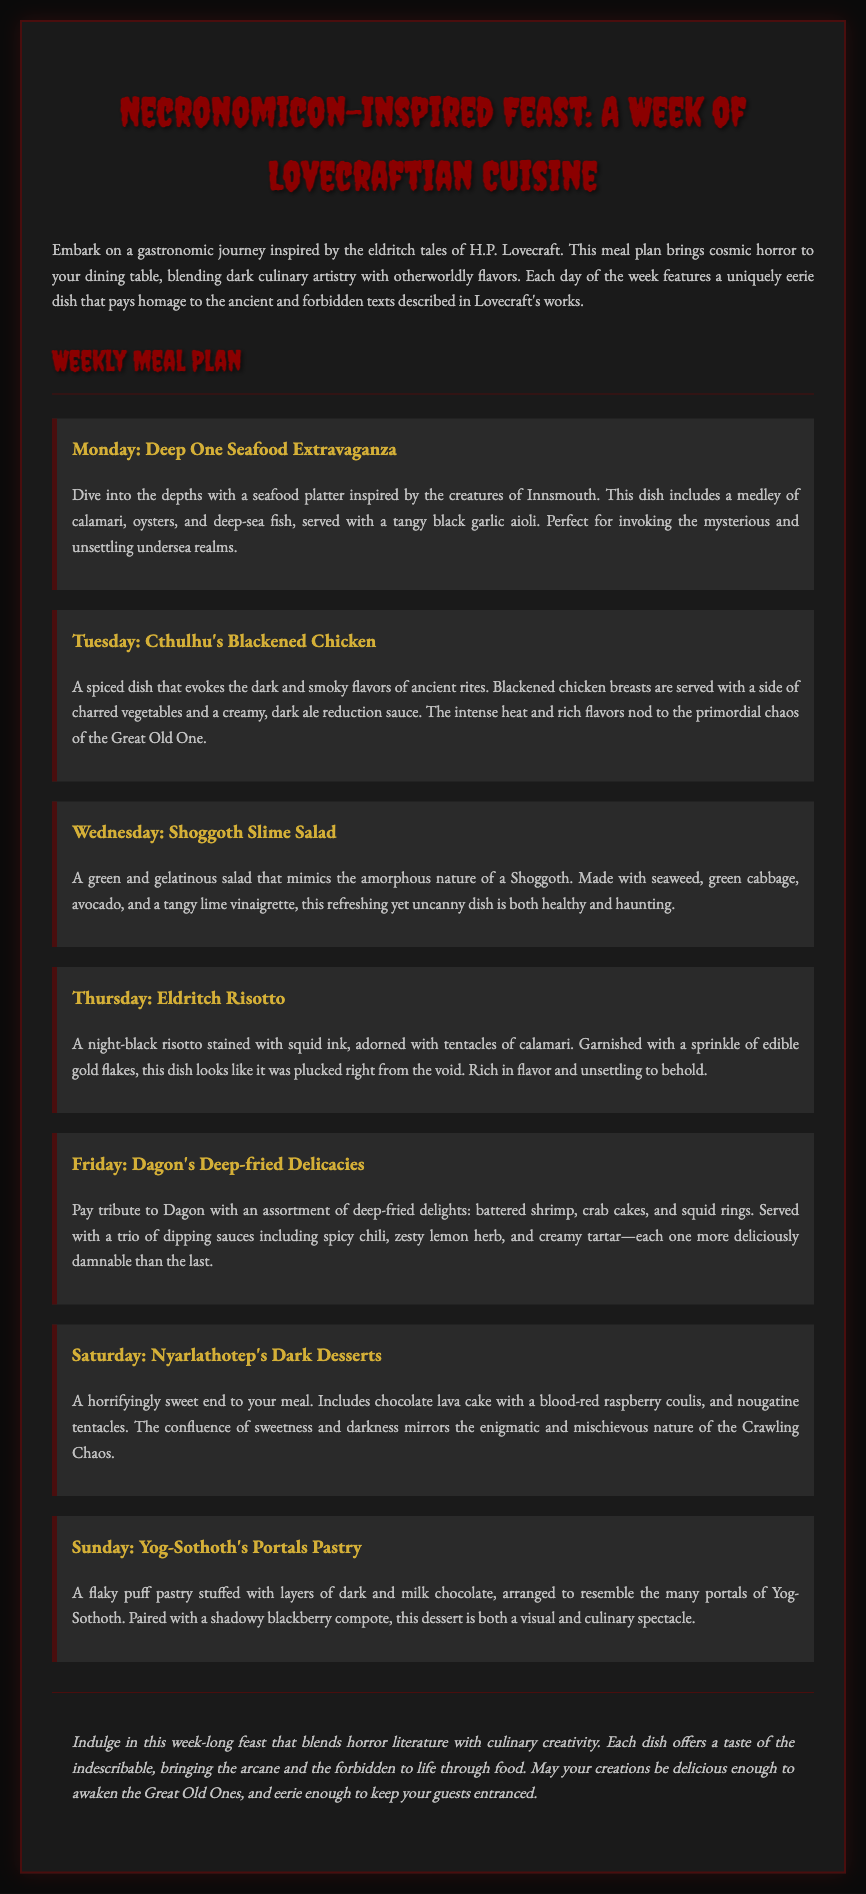What is the title of the meal plan? The title of the meal plan is prominently displayed at the top of the document.
Answer: Necronomicon-Inspired Feast: A Week of Lovecraftian Cuisine What type of cuisine is featured? The cuisine is described as being inspired by the works of H.P. Lovecraft, invoking a specific theme.
Answer: Lovecraftian Cuisine What dish is served on Monday? The dish for Monday is mentioned in the meal section of the document.
Answer: Deep One Seafood Extravaganza What is the main ingredient in the Eldritch Risotto? This dish is described with a specific ingredient that gives it its unique characteristic.
Answer: Squid ink How many different dipping sauces are served with Dagon's Deep-fried Delicacies? The document lists the number of dipping sauces provided with this dish.
Answer: Three What kind of dessert is included on Saturday? The dessert mentioned for Saturday is detailed in the relevant meal section.
Answer: Dark Desserts Name one ingredient in the Shoggoth Slime Salad. The salad is made up of several specific ingredients, one of which can be cited.
Answer: Seaweed Which day features a dish influenced by Cthulhu? The day associated with a theme related to Cthulhu can be located in the weekly schedule.
Answer: Tuesday What visual element is used to garnish the Eldritch Risotto? The document describes a specific garnish that enhances the dish's appearance.
Answer: Edible gold flakes 